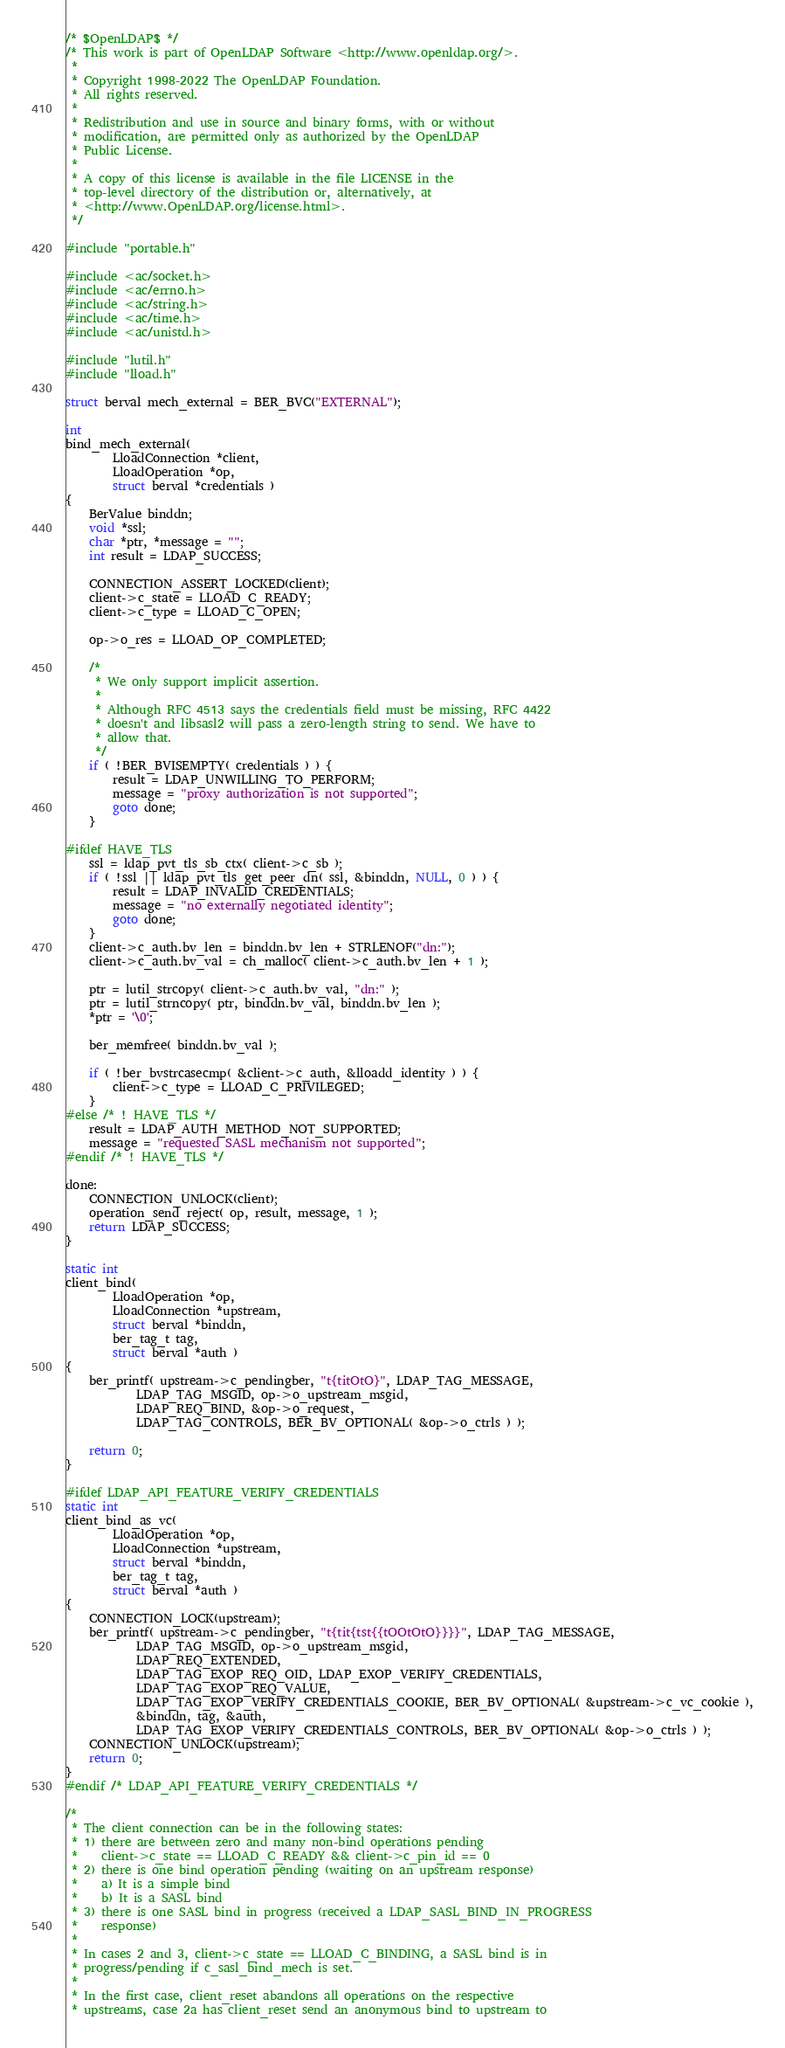<code> <loc_0><loc_0><loc_500><loc_500><_C_>/* $OpenLDAP$ */
/* This work is part of OpenLDAP Software <http://www.openldap.org/>.
 *
 * Copyright 1998-2022 The OpenLDAP Foundation.
 * All rights reserved.
 *
 * Redistribution and use in source and binary forms, with or without
 * modification, are permitted only as authorized by the OpenLDAP
 * Public License.
 *
 * A copy of this license is available in the file LICENSE in the
 * top-level directory of the distribution or, alternatively, at
 * <http://www.OpenLDAP.org/license.html>.
 */

#include "portable.h"

#include <ac/socket.h>
#include <ac/errno.h>
#include <ac/string.h>
#include <ac/time.h>
#include <ac/unistd.h>

#include "lutil.h"
#include "lload.h"

struct berval mech_external = BER_BVC("EXTERNAL");

int
bind_mech_external(
        LloadConnection *client,
        LloadOperation *op,
        struct berval *credentials )
{
    BerValue binddn;
    void *ssl;
    char *ptr, *message = "";
    int result = LDAP_SUCCESS;

    CONNECTION_ASSERT_LOCKED(client);
    client->c_state = LLOAD_C_READY;
    client->c_type = LLOAD_C_OPEN;

    op->o_res = LLOAD_OP_COMPLETED;

    /*
     * We only support implicit assertion.
     *
     * Although RFC 4513 says the credentials field must be missing, RFC 4422
     * doesn't and libsasl2 will pass a zero-length string to send. We have to
     * allow that.
     */
    if ( !BER_BVISEMPTY( credentials ) ) {
        result = LDAP_UNWILLING_TO_PERFORM;
        message = "proxy authorization is not supported";
        goto done;
    }

#ifdef HAVE_TLS
    ssl = ldap_pvt_tls_sb_ctx( client->c_sb );
    if ( !ssl || ldap_pvt_tls_get_peer_dn( ssl, &binddn, NULL, 0 ) ) {
        result = LDAP_INVALID_CREDENTIALS;
        message = "no externally negotiated identity";
        goto done;
    }
    client->c_auth.bv_len = binddn.bv_len + STRLENOF("dn:");
    client->c_auth.bv_val = ch_malloc( client->c_auth.bv_len + 1 );

    ptr = lutil_strcopy( client->c_auth.bv_val, "dn:" );
    ptr = lutil_strncopy( ptr, binddn.bv_val, binddn.bv_len );
    *ptr = '\0';

    ber_memfree( binddn.bv_val );

    if ( !ber_bvstrcasecmp( &client->c_auth, &lloadd_identity ) ) {
        client->c_type = LLOAD_C_PRIVILEGED;
    }
#else /* ! HAVE_TLS */
    result = LDAP_AUTH_METHOD_NOT_SUPPORTED;
    message = "requested SASL mechanism not supported";
#endif /* ! HAVE_TLS */

done:
    CONNECTION_UNLOCK(client);
    operation_send_reject( op, result, message, 1 );
    return LDAP_SUCCESS;
}

static int
client_bind(
        LloadOperation *op,
        LloadConnection *upstream,
        struct berval *binddn,
        ber_tag_t tag,
        struct berval *auth )
{
    ber_printf( upstream->c_pendingber, "t{titOtO}", LDAP_TAG_MESSAGE,
            LDAP_TAG_MSGID, op->o_upstream_msgid,
            LDAP_REQ_BIND, &op->o_request,
            LDAP_TAG_CONTROLS, BER_BV_OPTIONAL( &op->o_ctrls ) );

    return 0;
}

#ifdef LDAP_API_FEATURE_VERIFY_CREDENTIALS
static int
client_bind_as_vc(
        LloadOperation *op,
        LloadConnection *upstream,
        struct berval *binddn,
        ber_tag_t tag,
        struct berval *auth )
{
    CONNECTION_LOCK(upstream);
    ber_printf( upstream->c_pendingber, "t{tit{tst{{tOOtOtO}}}}", LDAP_TAG_MESSAGE,
            LDAP_TAG_MSGID, op->o_upstream_msgid,
            LDAP_REQ_EXTENDED,
            LDAP_TAG_EXOP_REQ_OID, LDAP_EXOP_VERIFY_CREDENTIALS,
            LDAP_TAG_EXOP_REQ_VALUE,
            LDAP_TAG_EXOP_VERIFY_CREDENTIALS_COOKIE, BER_BV_OPTIONAL( &upstream->c_vc_cookie ),
            &binddn, tag, &auth,
            LDAP_TAG_EXOP_VERIFY_CREDENTIALS_CONTROLS, BER_BV_OPTIONAL( &op->o_ctrls ) );
    CONNECTION_UNLOCK(upstream);
    return 0;
}
#endif /* LDAP_API_FEATURE_VERIFY_CREDENTIALS */

/*
 * The client connection can be in the following states:
 * 1) there are between zero and many non-bind operations pending
 *    client->c_state == LLOAD_C_READY && client->c_pin_id == 0
 * 2) there is one bind operation pending (waiting on an upstream response)
 *    a) It is a simple bind
 *    b) It is a SASL bind
 * 3) there is one SASL bind in progress (received a LDAP_SASL_BIND_IN_PROGRESS
 *    response)
 *
 * In cases 2 and 3, client->c_state == LLOAD_C_BINDING, a SASL bind is in
 * progress/pending if c_sasl_bind_mech is set.
 *
 * In the first case, client_reset abandons all operations on the respective
 * upstreams, case 2a has client_reset send an anonymous bind to upstream to</code> 